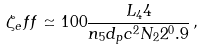Convert formula to latex. <formula><loc_0><loc_0><loc_500><loc_500>\zeta _ { e } f f \simeq 1 0 0 \frac { L _ { 4 } 4 } { n _ { 5 } d _ { p } c ^ { 2 } N _ { 2 } 2 ^ { 0 } . 9 } \, ,</formula> 